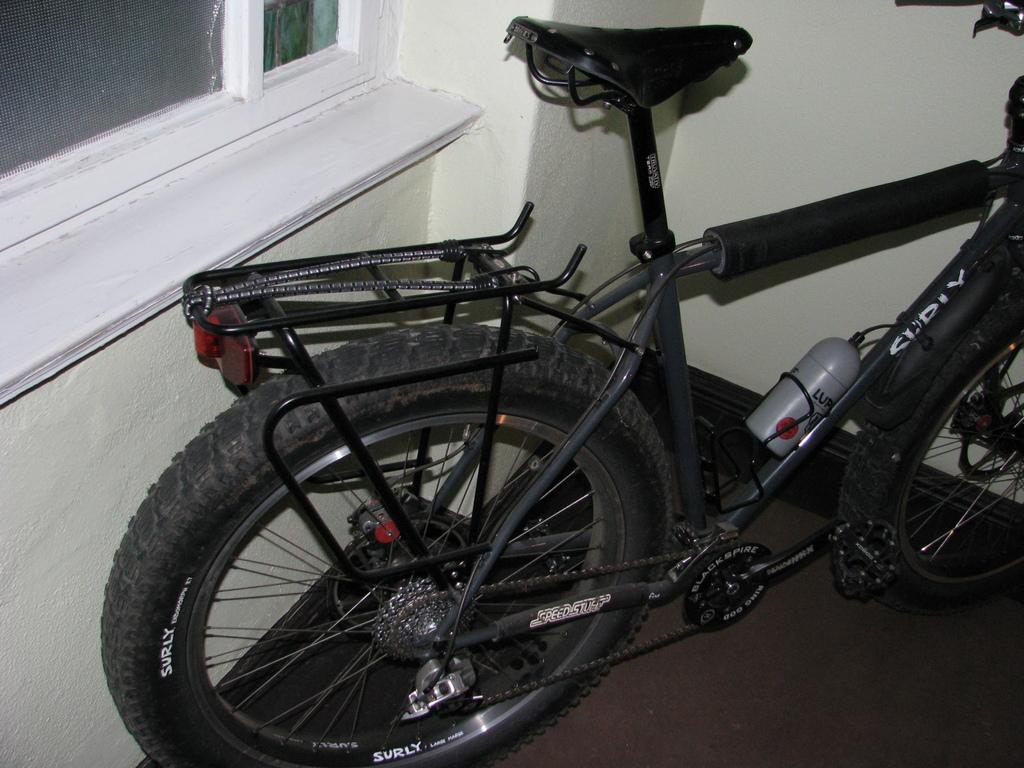What object is on the floor in the image? There is a bicycle on the floor. What can be seen on the wall on the left side of the image? There is a window on the wall on the left side. What type of pot is being used to rub the bicycle in the image? There is no pot or rubbing action present in the image; it only features a bicycle on the floor and a window on the wall. 